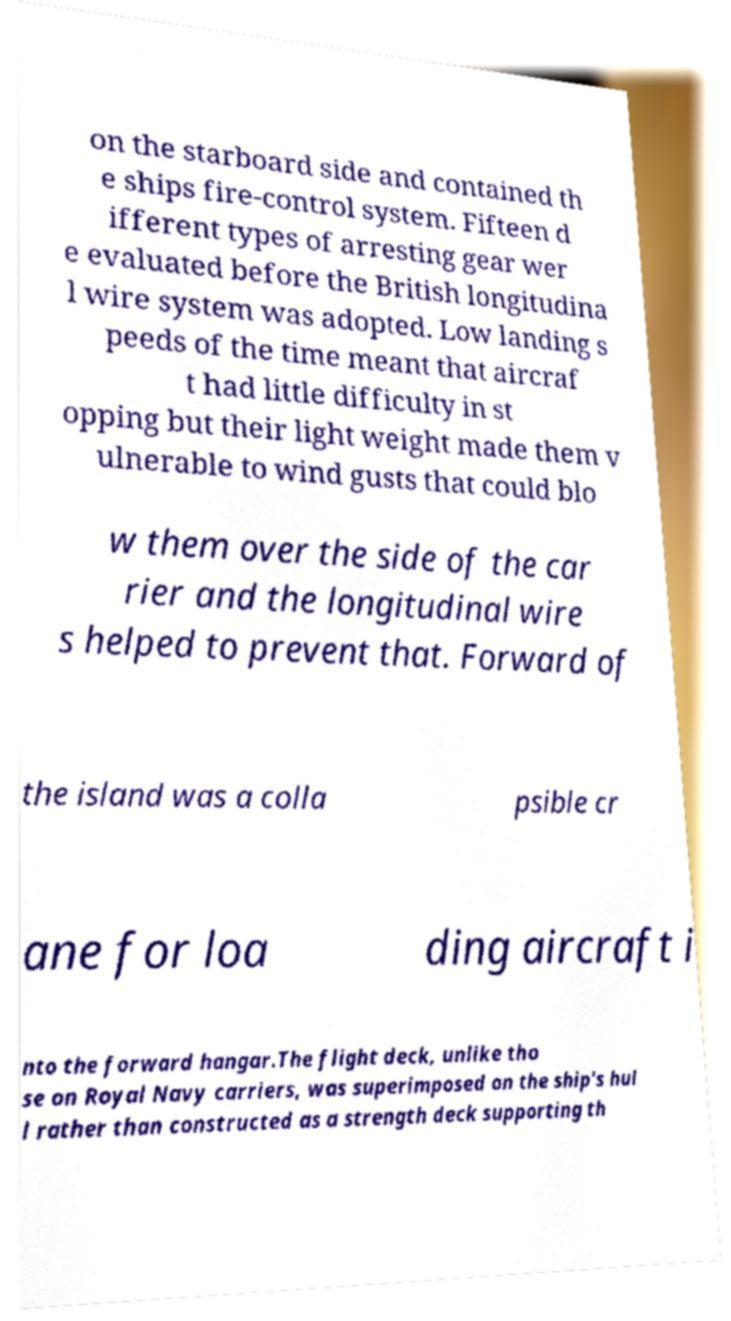Please identify and transcribe the text found in this image. on the starboard side and contained th e ships fire-control system. Fifteen d ifferent types of arresting gear wer e evaluated before the British longitudina l wire system was adopted. Low landing s peeds of the time meant that aircraf t had little difficulty in st opping but their light weight made them v ulnerable to wind gusts that could blo w them over the side of the car rier and the longitudinal wire s helped to prevent that. Forward of the island was a colla psible cr ane for loa ding aircraft i nto the forward hangar.The flight deck, unlike tho se on Royal Navy carriers, was superimposed on the ship's hul l rather than constructed as a strength deck supporting th 